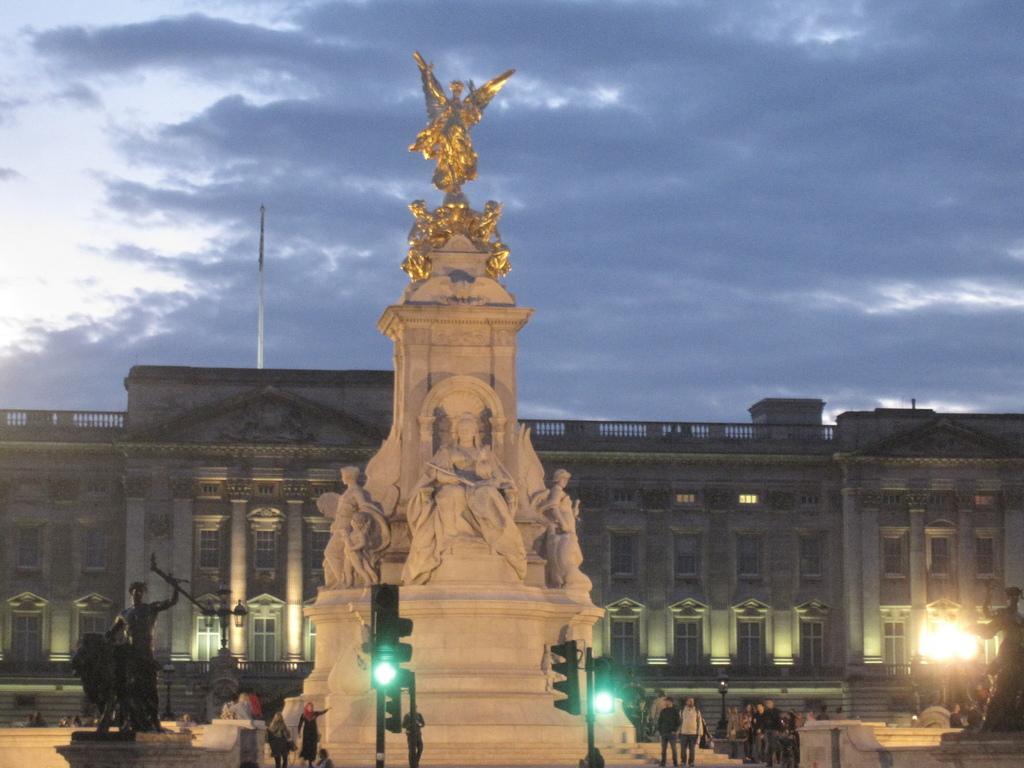How would you summarize this image in a sentence or two? In this picture we can see there are statues. In front of the statues there are groups of people. In front of the people there are poles with traffic signals and lights. Behind the statues there is a building, another pole and the sky. 